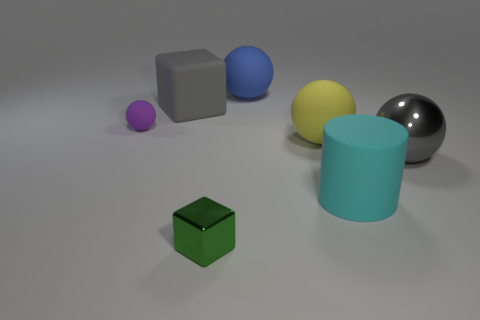Add 2 metallic cylinders. How many objects exist? 9 Subtract all cylinders. How many objects are left? 6 Subtract 0 blue blocks. How many objects are left? 7 Subtract all small red cylinders. Subtract all large rubber cylinders. How many objects are left? 6 Add 7 cubes. How many cubes are left? 9 Add 1 large gray metal spheres. How many large gray metal spheres exist? 2 